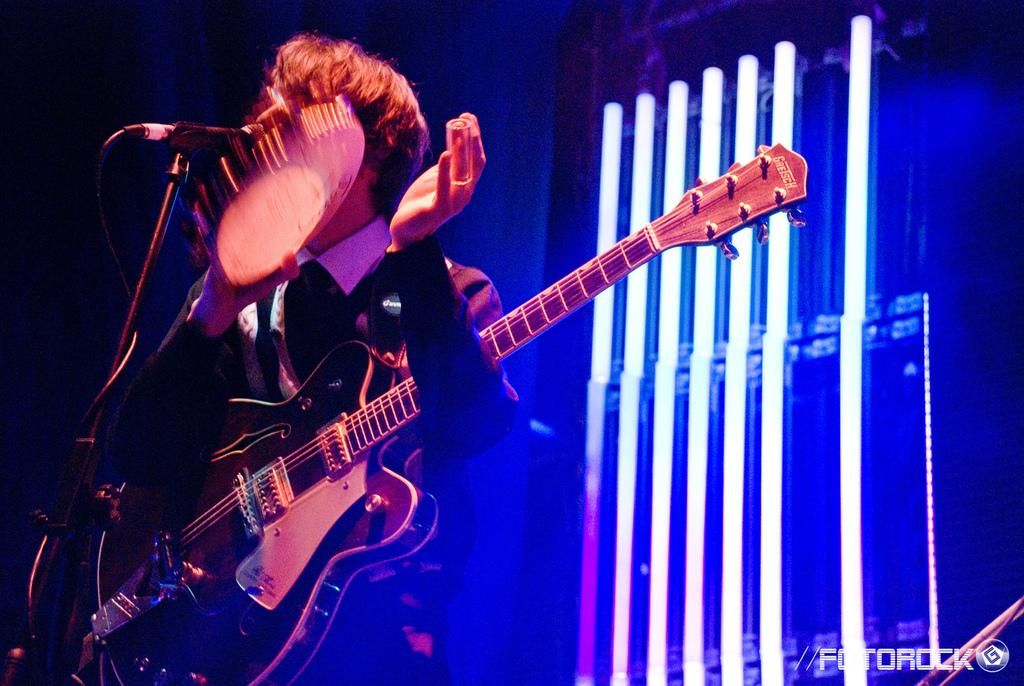What is the main subject of the image? The main subject of the image is a man. What is the man doing in the image? The man is standing and playing a musical instrument. What type of musical instrument is the man playing? The man is wearing a guitar, so he is playing a guitar. What is placed in front of the man? There is a microphone placed on a stand in front of the man. What can be seen in the background of the image? There are lights visible in the background of the image. What type of bottle is the man holding in the image? There is no bottle present in the image; the man is wearing a guitar and playing it. Can you tell me how many bears are visible in the image? There are no bears present in the image. 